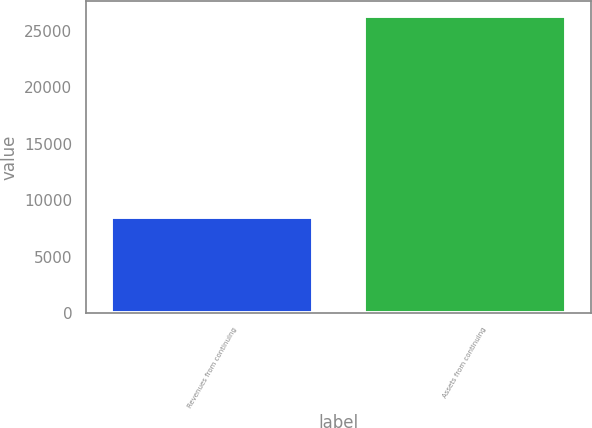Convert chart. <chart><loc_0><loc_0><loc_500><loc_500><bar_chart><fcel>Revenues from continuing<fcel>Assets from continuing<nl><fcel>8542.5<fcel>26325<nl></chart> 